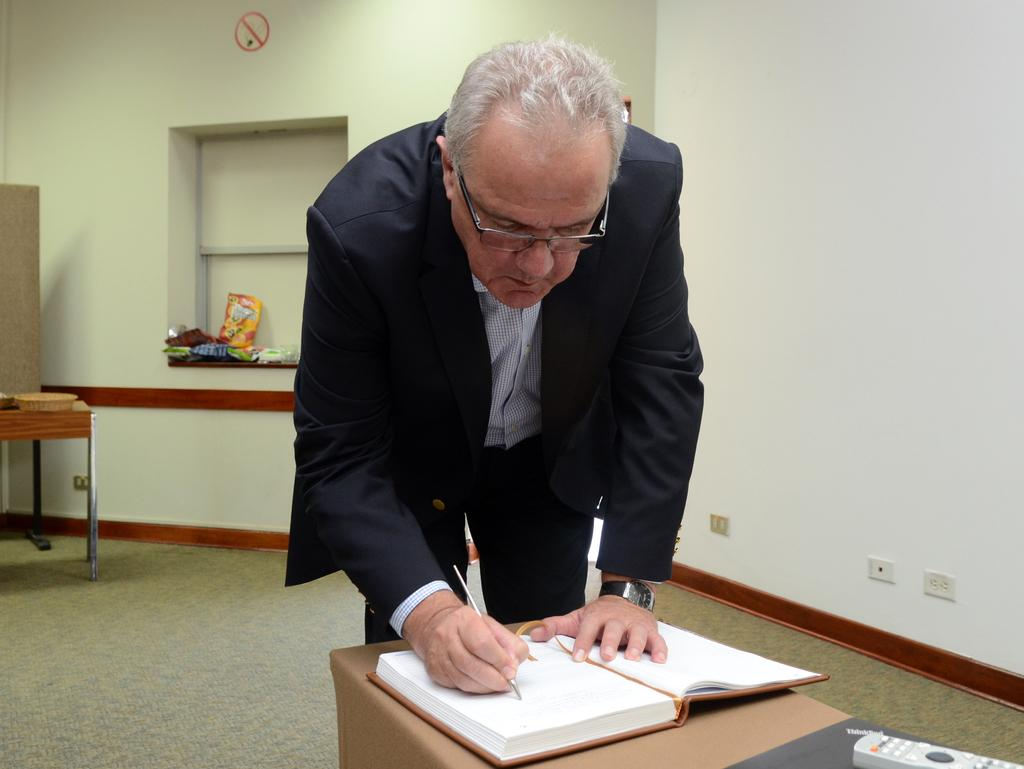What is the person in the image doing? The person is standing and writing. Can you describe the person's appearance? The person is wearing glasses. What objects are on the table in the image? There is a book, a remote, and a basket on the table. What can be seen in the background of the image? There is a wall and objects in the background. Is the floor visible in the image? Yes, the floor is visible. What type of wool is being used to expand the wall in the image? There is no wool or expansion of the wall in the image; it only shows a person standing and writing, with a wall in the background. 